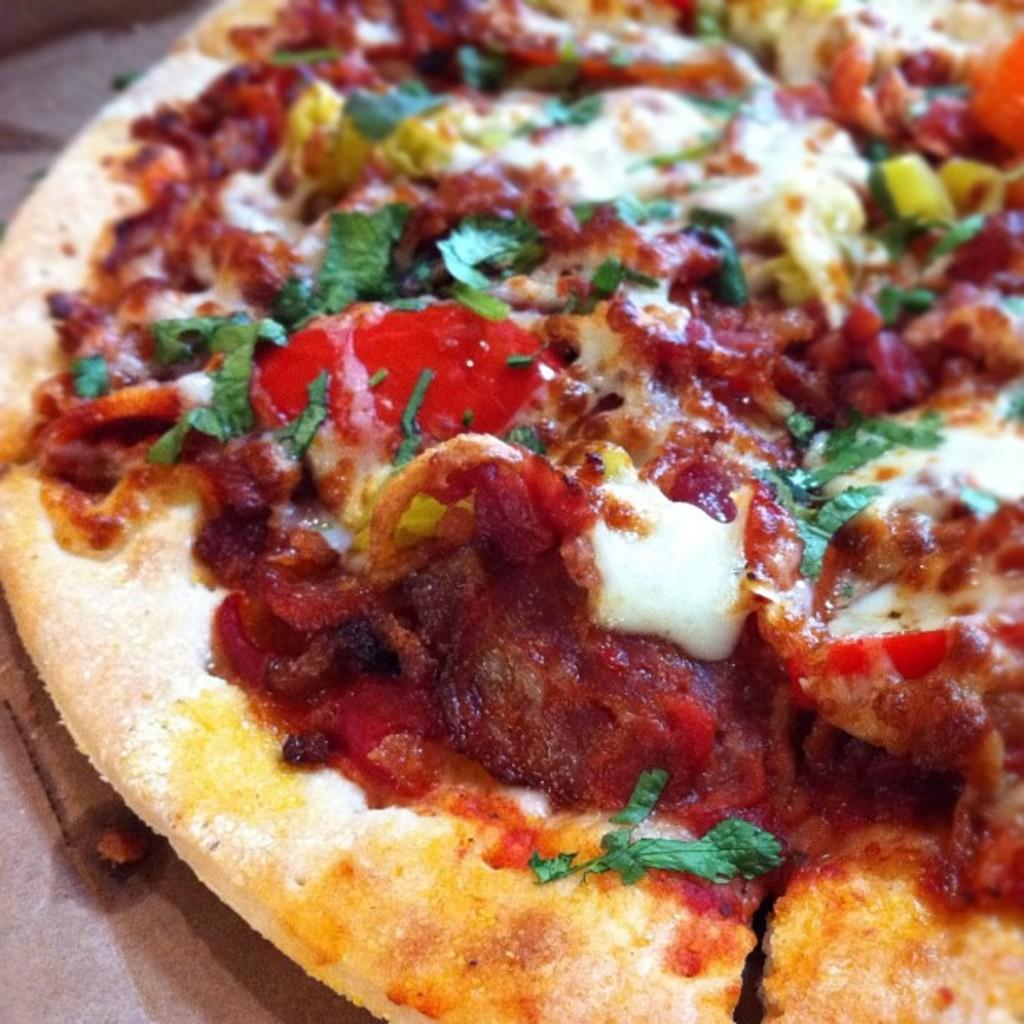What type of food is shown in the image? There is a pizza in the image. Can you describe the pizza in the image? The image shows a pizza, but it does not provide any specific details about its toppings or appearance. What might someone be doing with the pizza in the image? The image does not show anyone interacting with the pizza, so it is unclear what someone might be doing with it. What date is circled on the calendar in the image? There is no calendar present in the image, so it is not possible to answer that question. 